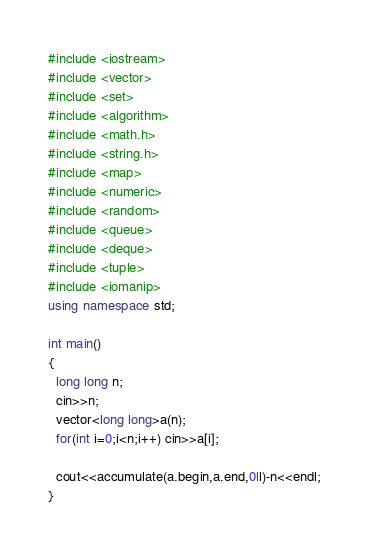<code> <loc_0><loc_0><loc_500><loc_500><_C++_>#include <iostream>
#include <vector>
#include <set>
#include <algorithm>
#include <math.h>
#include <string.h>
#include <map>
#include <numeric>
#include <random>
#include <queue>
#include <deque>
#include <tuple>
#include <iomanip>
using namespace std;

int main()
{
  long long n;
  cin>>n;
  vector<long long>a(n);
  for(int i=0;i<n;i++) cin>>a[i];

  cout<<accumulate(a.begin,a.end,0ll)-n<<endl;
}
</code> 